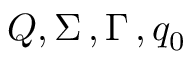<formula> <loc_0><loc_0><loc_500><loc_500>Q , \Sigma \, , \Gamma \, , q _ { 0 }</formula> 